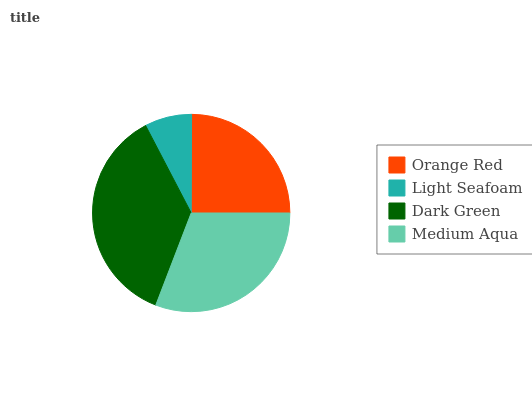Is Light Seafoam the minimum?
Answer yes or no. Yes. Is Dark Green the maximum?
Answer yes or no. Yes. Is Dark Green the minimum?
Answer yes or no. No. Is Light Seafoam the maximum?
Answer yes or no. No. Is Dark Green greater than Light Seafoam?
Answer yes or no. Yes. Is Light Seafoam less than Dark Green?
Answer yes or no. Yes. Is Light Seafoam greater than Dark Green?
Answer yes or no. No. Is Dark Green less than Light Seafoam?
Answer yes or no. No. Is Medium Aqua the high median?
Answer yes or no. Yes. Is Orange Red the low median?
Answer yes or no. Yes. Is Orange Red the high median?
Answer yes or no. No. Is Medium Aqua the low median?
Answer yes or no. No. 